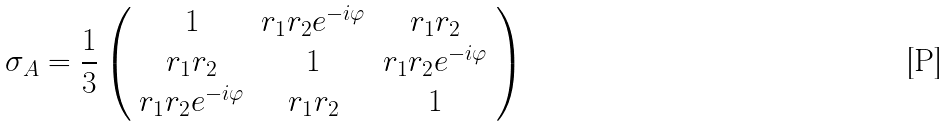Convert formula to latex. <formula><loc_0><loc_0><loc_500><loc_500>\sigma _ { A } = \frac { 1 } { 3 } \left ( \begin{array} { c c c } 1 & r _ { 1 } r _ { 2 } e ^ { - i \varphi } & r _ { 1 } r _ { 2 } \\ r _ { 1 } r _ { 2 } & 1 & r _ { 1 } r _ { 2 } e ^ { - i \varphi } \\ r _ { 1 } r _ { 2 } e ^ { - i \varphi } & r _ { 1 } r _ { 2 } & 1 \end{array} \right )</formula> 